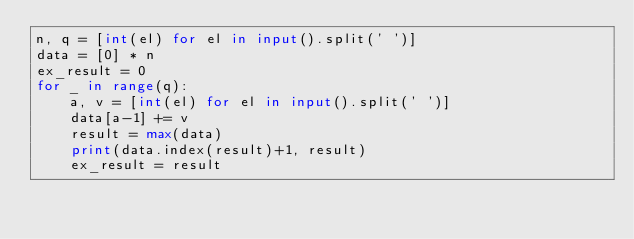Convert code to text. <code><loc_0><loc_0><loc_500><loc_500><_Python_>n, q = [int(el) for el in input().split(' ')]
data = [0] * n
ex_result = 0
for _ in range(q):
    a, v = [int(el) for el in input().split(' ')]
    data[a-1] += v
    result = max(data)
    print(data.index(result)+1, result)
    ex_result = result</code> 